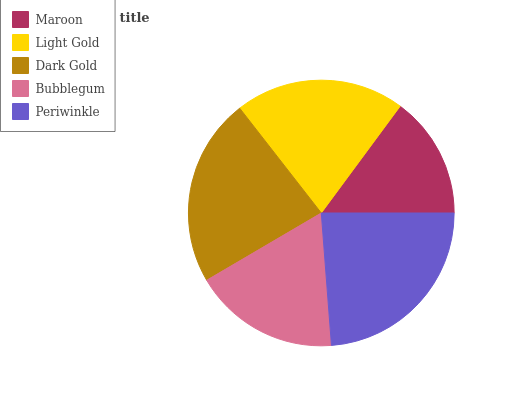Is Maroon the minimum?
Answer yes or no. Yes. Is Periwinkle the maximum?
Answer yes or no. Yes. Is Light Gold the minimum?
Answer yes or no. No. Is Light Gold the maximum?
Answer yes or no. No. Is Light Gold greater than Maroon?
Answer yes or no. Yes. Is Maroon less than Light Gold?
Answer yes or no. Yes. Is Maroon greater than Light Gold?
Answer yes or no. No. Is Light Gold less than Maroon?
Answer yes or no. No. Is Light Gold the high median?
Answer yes or no. Yes. Is Light Gold the low median?
Answer yes or no. Yes. Is Bubblegum the high median?
Answer yes or no. No. Is Maroon the low median?
Answer yes or no. No. 